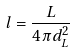<formula> <loc_0><loc_0><loc_500><loc_500>l = \frac { L } { 4 \pi d _ { L } ^ { 2 } }</formula> 